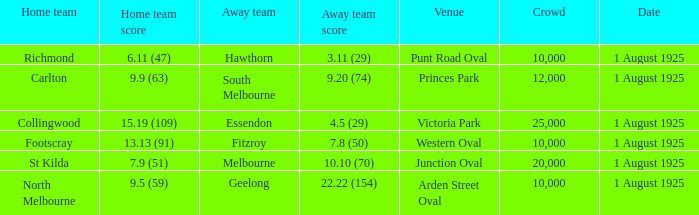Which team plays home at Princes Park? Carlton. 